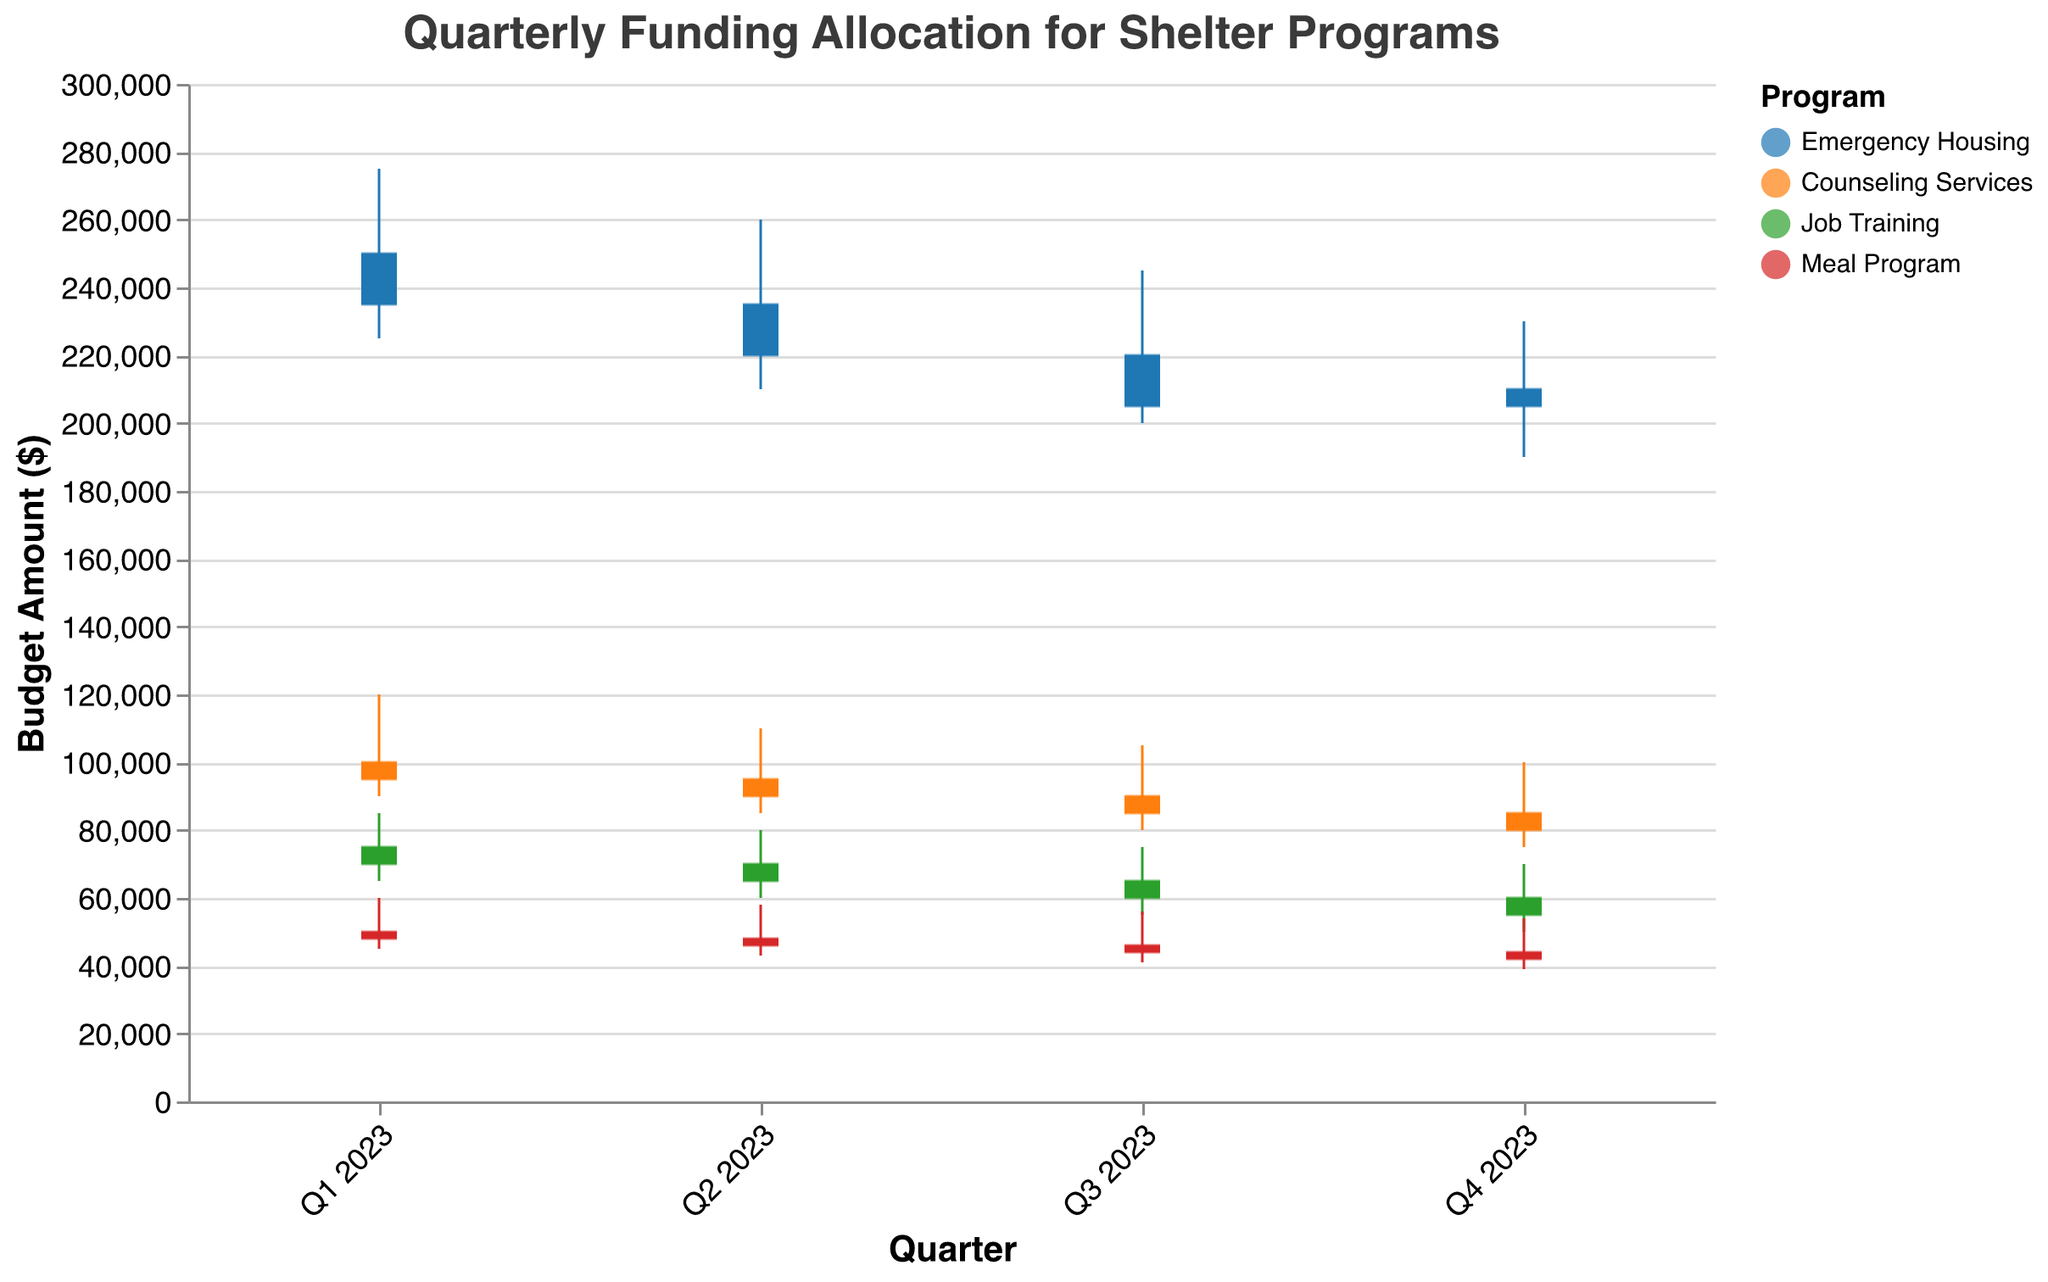What is the title of the figure? The title of the figure is prominently displayed at the top and usually gives a summary of what the figure depicts. In this case, it describes the overall topic of the chart.
Answer: Quarterly Funding Allocation for Shelter Programs Which program had the highest initial budget in Q1 2023? To determine this, look at the position of the initial budget value for each program in Q1 2023 and identify the highest one. Emergency Housing has the highest initial budget with $250,000.
Answer: Emergency Housing What is the minimum amount spent on the Meal Program in Q3 2023? Check the range bar for the Meal Program during Q3 2023 and find the endpoint that denotes the minimum spent amount. It shows $41,000.
Answer: $41,000 For which program did the closing balance exceed the initial budget in any quarter? Compare the initial budget and closing balance for all quarters across all programs. Note that the closing balance never exceeds the initial budget in any of the programs.
Answer: None How much did the Counseling Services program's budget decrease from Q1 2023 to Q4 2023? Subtract the initial budget in Q4 2023 from the initial budget in Q1 2023 for the Counseling Services program. The decrease is $100,000 - $85,000 = $15,000.
Answer: $15,000 Which program had the most spending range in Q2 2023? The spending range is derived from subtracting the minimum spent from the maximum spent. Emergency Housing had a range of $50,000 ($260,000 - $210,000), Counseling Services $25,000 ($110,000 - $85,000), Job Training $20,000 ($80,000 - $60,000), and Meal Program $15,000 ($58,000 - $43,000). So, Emergency Housing had the most spending range.
Answer: Emergency Housing Did the closing balance for any quarter in Emergency Housing increase compared to the previous quarter? If yes, when? Check the closing balance for each quarter in Emergency Housing and compare sequentially. The closing balances are: Q1 ($235,000), Q2 ($220,000), Q3 ($205,000), Q4 ($210,000). The only increase is from Q3 to Q4.
Answer: Yes, in Q4 2023 What is the average initial budget of the Job Training program across all quarters in 2023? Divide the sum of the initial budgets by the number of quarters. The initial budgets are: $75,000, $70,000, $65,000, $60,000. Thus, the average is ($75,000 + $70,000 + $65,000 + $60,000) / 4 = $67,500.
Answer: $67,500 Which program had the smallest closing balance in Q4 2023? Compare the closing balances for Q4 2023 across all programs and find the smallest. Job Training had a closing balance of $55,000, Counseling Services $80,000, Emergency Housing $210,000, and Meal Program $42,000. So, Meal Program has the smallest closing balance.
Answer: Meal Program 